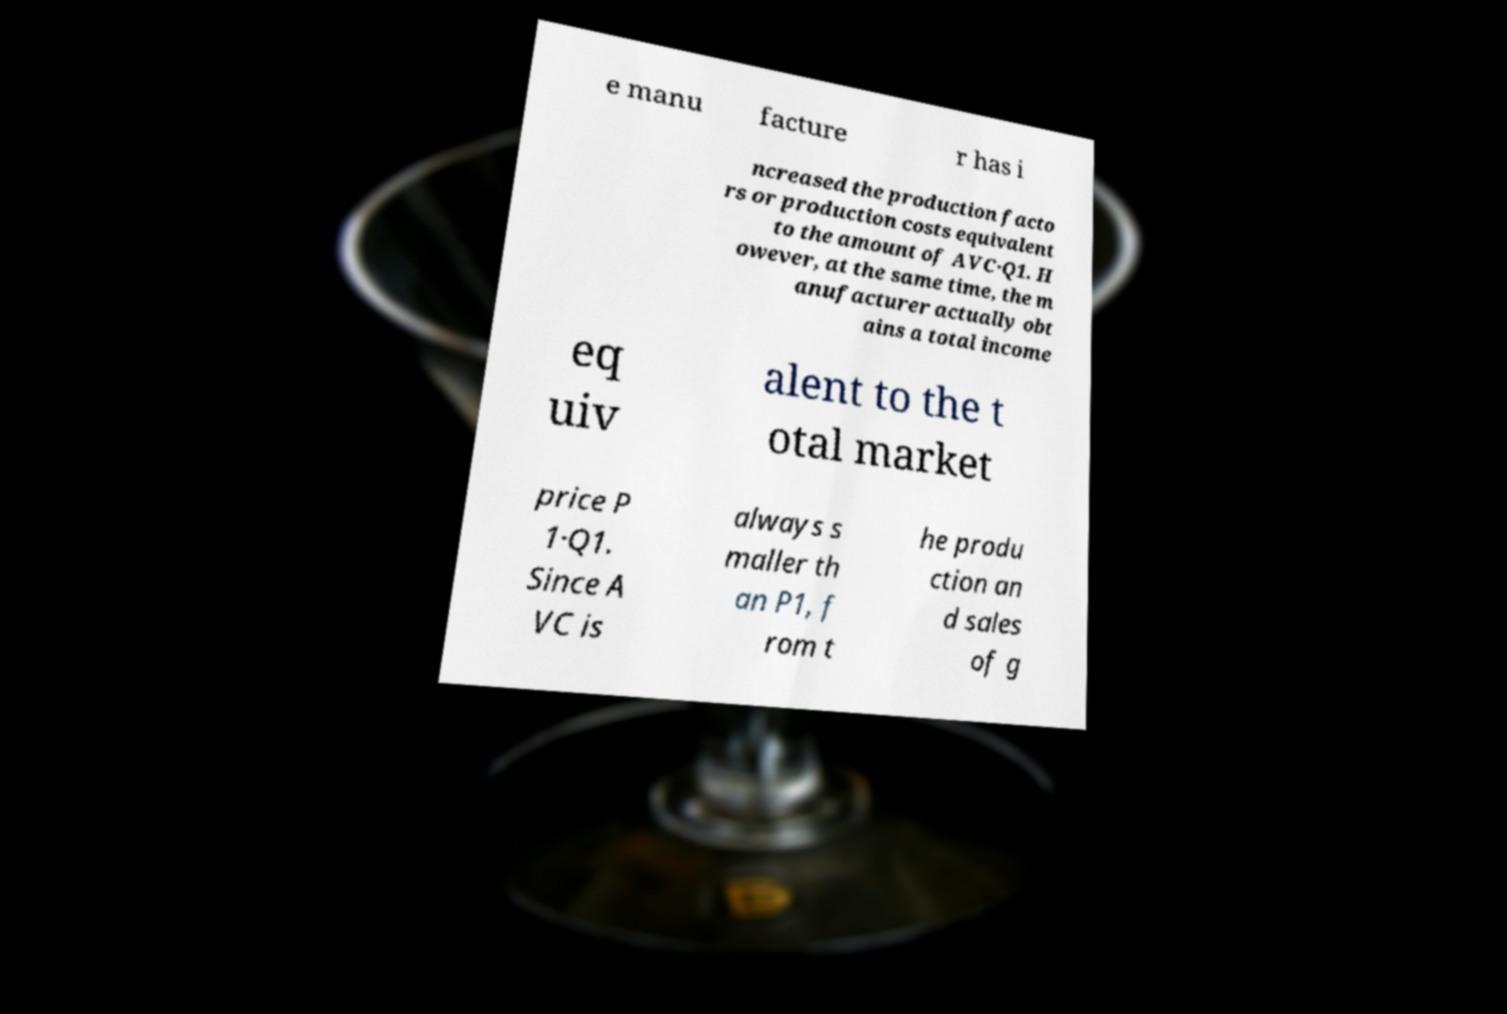I need the written content from this picture converted into text. Can you do that? e manu facture r has i ncreased the production facto rs or production costs equivalent to the amount of AVC·Q1. H owever, at the same time, the m anufacturer actually obt ains a total income eq uiv alent to the t otal market price P 1·Q1. Since A VC is always s maller th an P1, f rom t he produ ction an d sales of g 